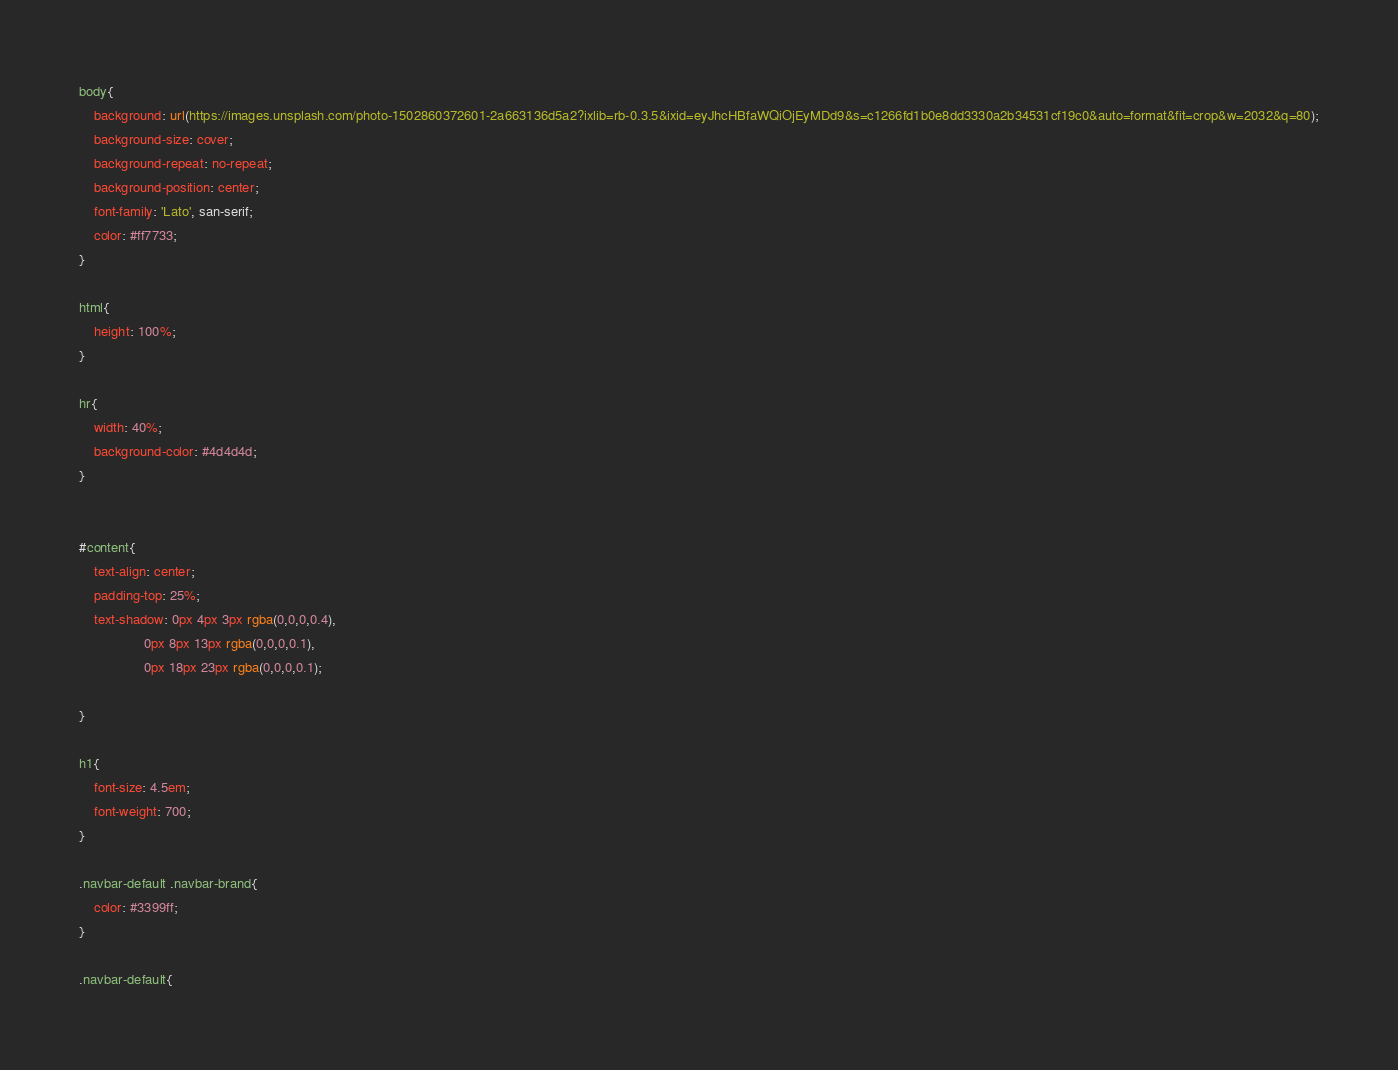Convert code to text. <code><loc_0><loc_0><loc_500><loc_500><_CSS_>body{
	background: url(https://images.unsplash.com/photo-1502860372601-2a663136d5a2?ixlib=rb-0.3.5&ixid=eyJhcHBfaWQiOjEyMDd9&s=c1266fd1b0e8dd3330a2b34531cf19c0&auto=format&fit=crop&w=2032&q=80);
	background-size: cover;
	background-repeat: no-repeat;
	background-position: center;
	font-family: 'Lato', san-serif;
	color: #ff7733;
}	

html{
	height: 100%;
}

hr{
	width: 40%;
	background-color: #4d4d4d;
}


#content{
	text-align: center;
	padding-top: 25%;
	text-shadow: 0px 4px 3px rgba(0,0,0,0.4),
			     0px 8px 13px rgba(0,0,0,0.1),
			     0px 18px 23px rgba(0,0,0,0.1);

}

h1{
	font-size: 4.5em;
	font-weight: 700;
}

.navbar-default .navbar-brand{
	color: #3399ff;
}

.navbar-default{</code> 